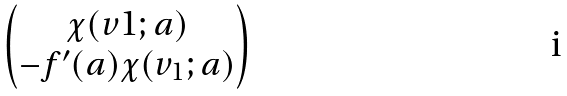<formula> <loc_0><loc_0><loc_500><loc_500>\begin{pmatrix} \chi ( v 1 ; a ) \\ - f ^ { \prime } ( a ) \chi ( v _ { 1 } ; a ) \end{pmatrix}</formula> 